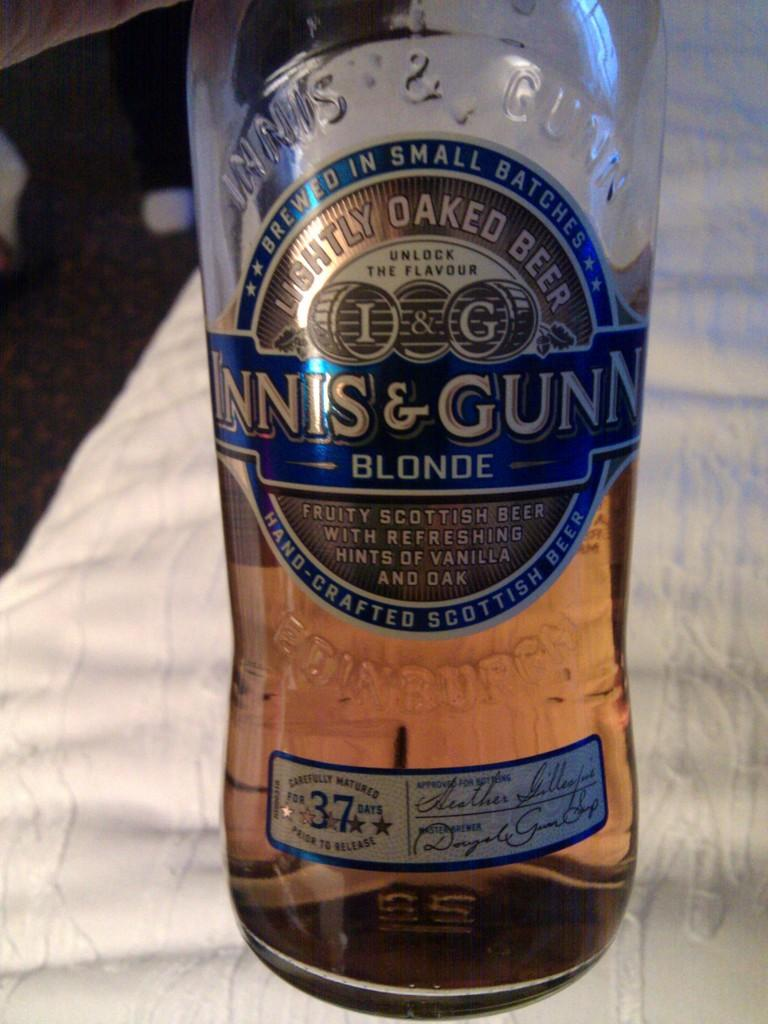<image>
Write a terse but informative summary of the picture. A bottle of Innis & Gunn Blonde ale is half full. 